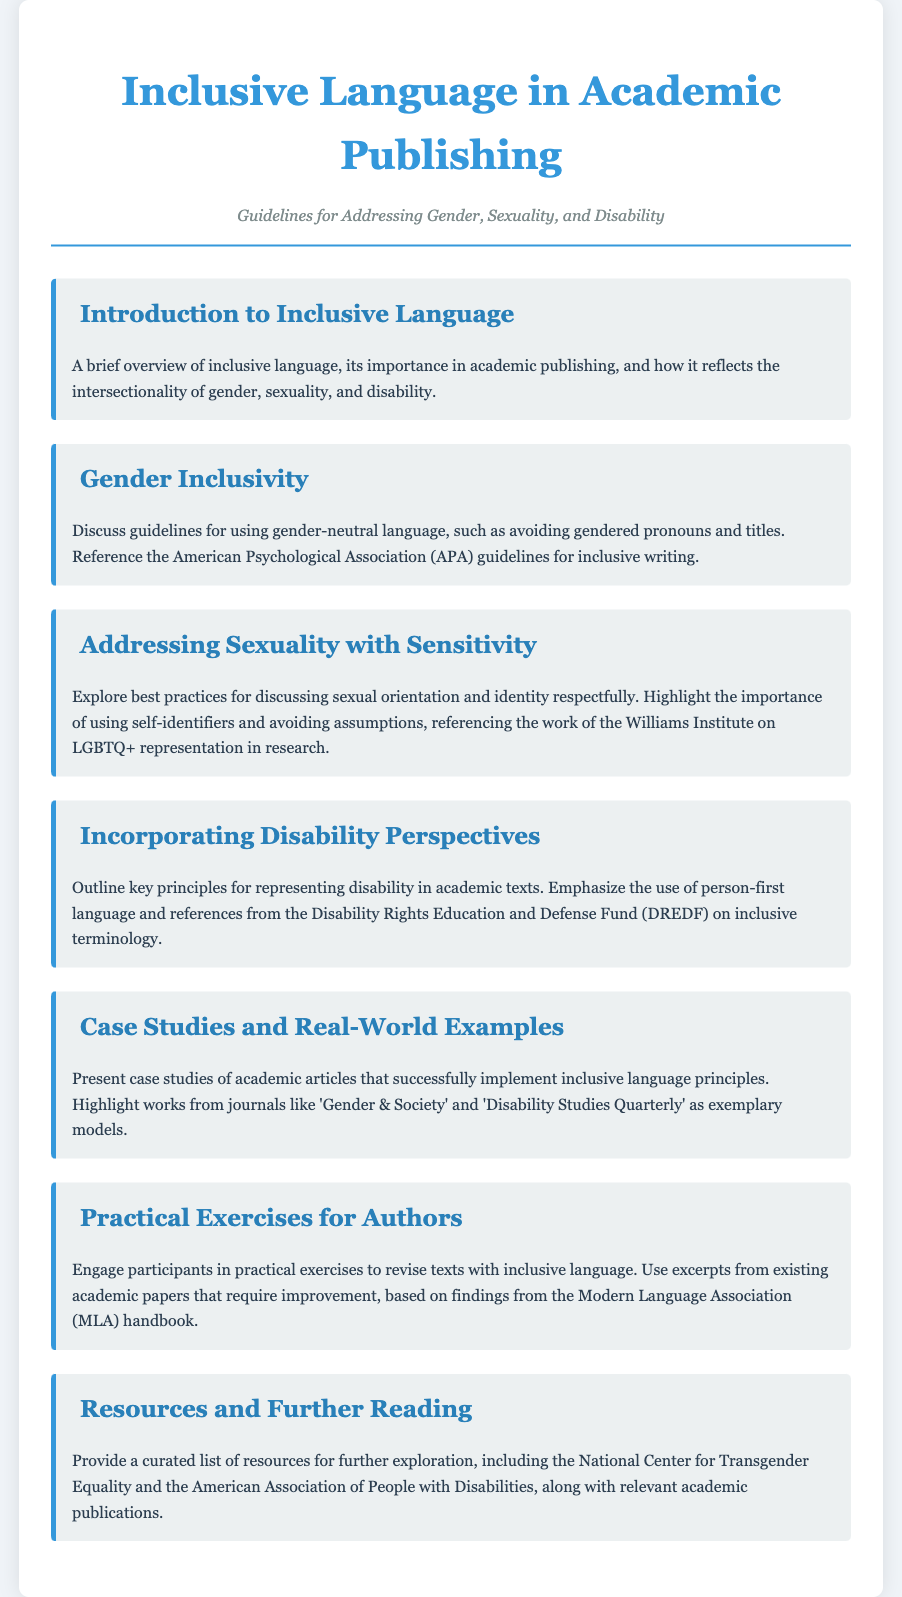What is the title of the document? The title of the document is shown prominently at the top of the rendered page.
Answer: Inclusive Language in Academic Publishing Who authored the document? The author is indicated in the header section below the title.
Answer: Guidelines for Addressing Gender, Sexuality, and Disability What is addressed in the section titled "Gender Inclusivity"? This section discusses guidelines for using gender-neutral language along with specific stylistic references.
Answer: Guidelines for using gender-neutral language What organization is referenced for inclusive writing guidelines? The document mentions a specific organization that provides guidelines for academic writing.
Answer: American Psychological Association Which icon is used for the "Incorporating Disability Perspectives" section? The icon accompanying this section provides a visual cue related to its topic.
Answer: Wheelchair What journals are highlighted as exemplary models in the case studies section? The document lists specific journals that have successfully implemented inclusive language principles.
Answer: Gender & Society and Disability Studies Quarterly What type of exercises are suggested for authors? This section specifies hands-on activities for participants to engage with the material.
Answer: Practical exercises to revise texts How many main agenda items are included in the document? The number of individual agenda items provides insights into the scope of the document.
Answer: Seven 